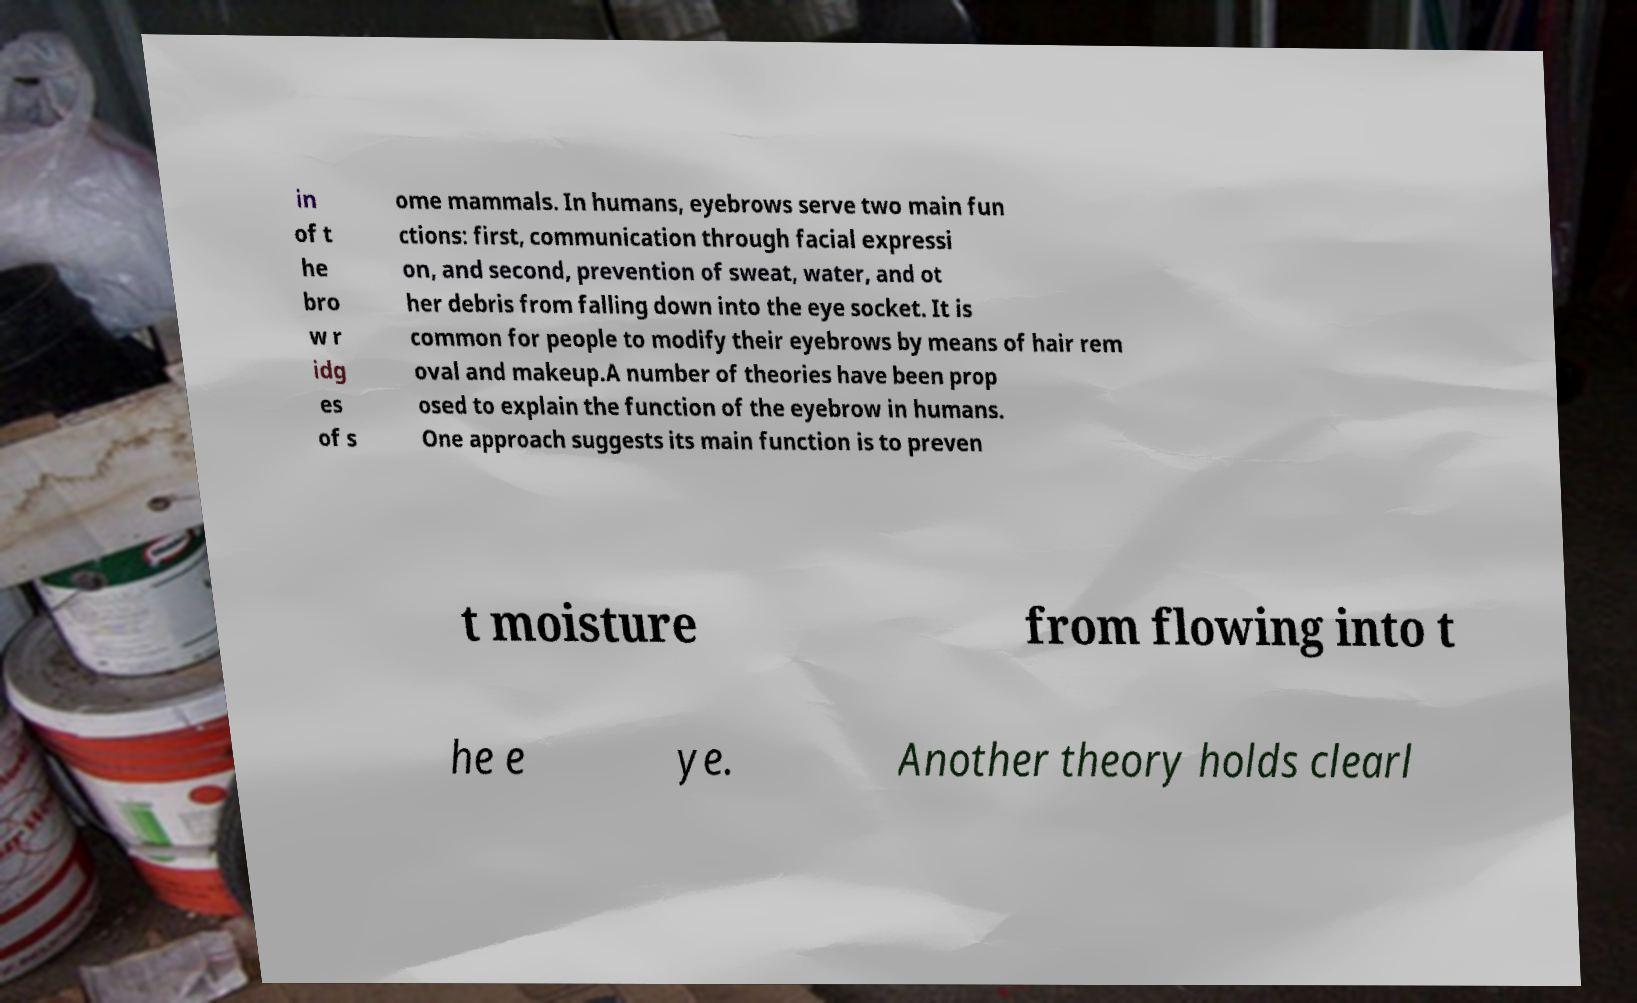There's text embedded in this image that I need extracted. Can you transcribe it verbatim? in of t he bro w r idg es of s ome mammals. In humans, eyebrows serve two main fun ctions: first, communication through facial expressi on, and second, prevention of sweat, water, and ot her debris from falling down into the eye socket. It is common for people to modify their eyebrows by means of hair rem oval and makeup.A number of theories have been prop osed to explain the function of the eyebrow in humans. One approach suggests its main function is to preven t moisture from flowing into t he e ye. Another theory holds clearl 